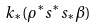Convert formula to latex. <formula><loc_0><loc_0><loc_500><loc_500>k _ { * } ( \rho ^ { * } s ^ { * } s _ { * } \beta )</formula> 